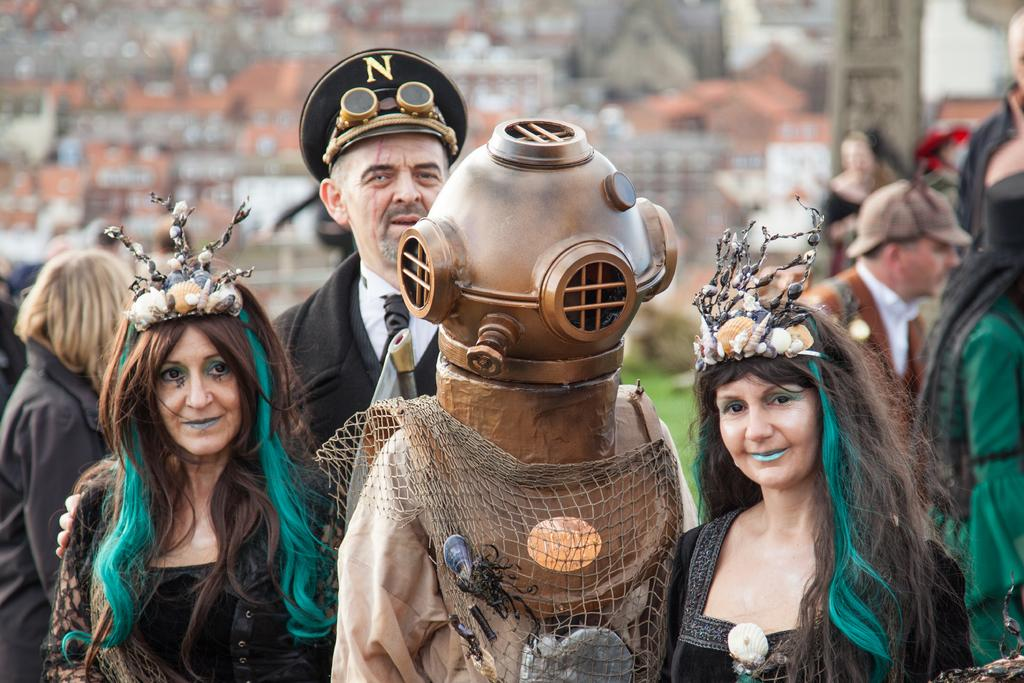Who or what can be seen in the image? There are people in the image. What are the people wearing? The people are wearing costumes. What can be seen in the background of the image? There is a wall in the background of the image. Can you describe the appearance of one of the people in the image? A man in the image is wearing a cap. What type of natural environment is visible in the image? There is grass visible in the image. What type of food is being served in the vase in the image? There is no vase or food present in the image. What curve can be seen in the image? There is no curve visible in the image. 